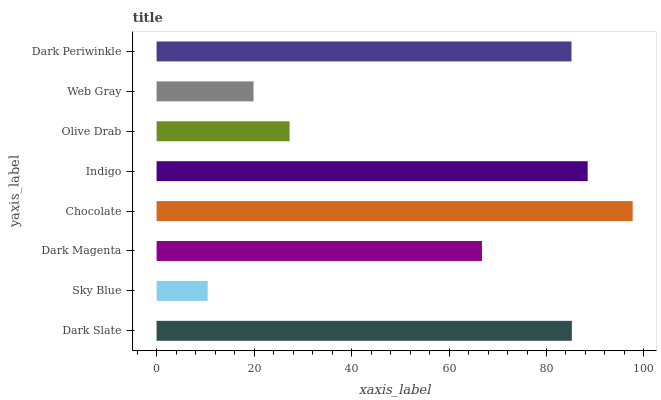Is Sky Blue the minimum?
Answer yes or no. Yes. Is Chocolate the maximum?
Answer yes or no. Yes. Is Dark Magenta the minimum?
Answer yes or no. No. Is Dark Magenta the maximum?
Answer yes or no. No. Is Dark Magenta greater than Sky Blue?
Answer yes or no. Yes. Is Sky Blue less than Dark Magenta?
Answer yes or no. Yes. Is Sky Blue greater than Dark Magenta?
Answer yes or no. No. Is Dark Magenta less than Sky Blue?
Answer yes or no. No. Is Dark Periwinkle the high median?
Answer yes or no. Yes. Is Dark Magenta the low median?
Answer yes or no. Yes. Is Dark Slate the high median?
Answer yes or no. No. Is Dark Periwinkle the low median?
Answer yes or no. No. 